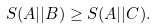<formula> <loc_0><loc_0><loc_500><loc_500>S ( A | | B ) \geq S ( A | | C ) .</formula> 